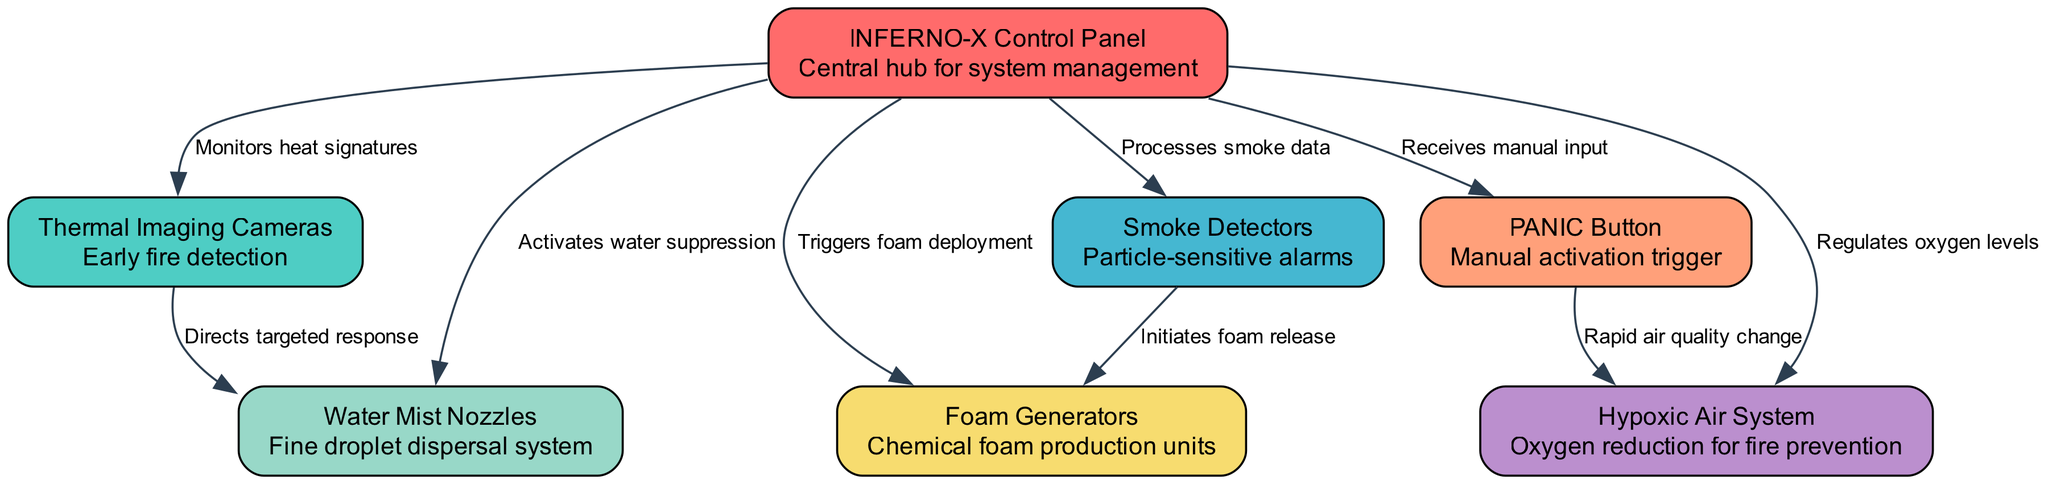What is the total number of nodes in the diagram? The diagram lists a series of distinct components identified by unique IDs. Counting these nodes gives a total of 7 distinct components: INFERNO-X Control Panel, Thermal Imaging Cameras, Smoke Detectors, PANIC Button, Water Mist Nozzles, Foam Generators, and Hypoxic Air System.
Answer: 7 What is the function of the Thermal Imaging Cameras? The Thermal Imaging Cameras are described under their respective node as "Early fire detection." This indicates their primary function in the system.
Answer: Early fire detection Which node is activated by the PANIC Button? The PANIC Button, as indicated in the edges, connects to the Hypoxic Air System with the label "Rapid air quality change," signifying that it triggers action in that component specifically.
Answer: Hypoxic Air System What triggers the deployment of the Foam Generators? The edge originating from the Smoke Detectors points to the Foam Generators with the label "Initiates foam release," meaning that the activation of Foam Generators is contingent upon the Smoke Detectors detecting smoke.
Answer: Smoke Detectors How many edges connect to the INFERNO-X Control Panel? The INFERNO-X Control Panel is linked to 6 different nodes through the edges outlined in the diagram, indicating six activation or monitoring connections.
Answer: 6 What is the relationship between the Thermal Imaging Cameras and the Water Mist Nozzles? The Thermal Imaging Cameras connect to the INFERNO-X Control Panel, which subsequently activates the Water Mist Nozzles, creating an indirect relationship where the Cameras help in triggering the Water Mist system.
Answer: Indirect connection via INFERNO-X Control Panel What does the INFERNO-X Control Panel regulate? The edges indicate that the INFERNO-X Control Panel regulates multiple functions, including activating the Water Mist Nozzles, Foam Generators, and controlling the Hypoxic Air System, indicating its central role in managing fire suppression actions.
Answer: Water Mist Nozzles, Foam Generators, and Hypoxic Air System What technology is used for fine droplet dispersal? The diagram specifies the Water Mist Nozzles as the component responsible for "Fine droplet dispersal system," indicating the method utilized for suppression.
Answer: Water Mist Nozzles Which component processes smoke data? According to the diagram, the INFERNO-X Control Panel processes smoke data received from the Smoke Detectors, highlighting its analytical role in the system.
Answer: INFERNO-X Control Panel What does the Hypoxic Air System aim to achieve? The description states that the Hypoxic Air System is responsible for "Oxygen reduction for fire prevention," clarifying its intended purpose in this fire suppression system.
Answer: Oxygen reduction for fire prevention 